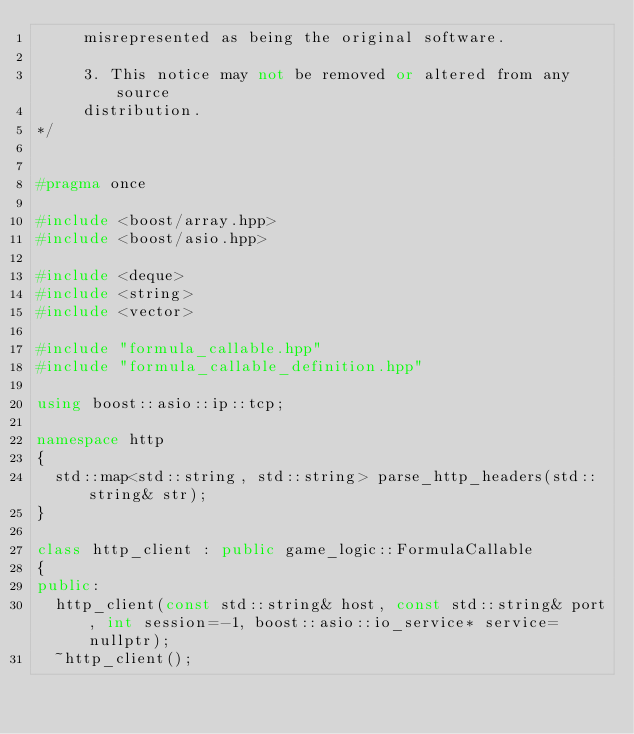Convert code to text. <code><loc_0><loc_0><loc_500><loc_500><_C++_>	   misrepresented as being the original software.

	   3. This notice may not be removed or altered from any source
	   distribution.
*/


#pragma once

#include <boost/array.hpp>
#include <boost/asio.hpp>

#include <deque>
#include <string>
#include <vector>

#include "formula_callable.hpp"
#include "formula_callable_definition.hpp"

using boost::asio::ip::tcp;

namespace http
{
	std::map<std::string, std::string> parse_http_headers(std::string& str);
}

class http_client : public game_logic::FormulaCallable
{
public:
	http_client(const std::string& host, const std::string& port, int session=-1, boost::asio::io_service* service=nullptr);
	~http_client();</code> 